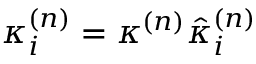<formula> <loc_0><loc_0><loc_500><loc_500>\kappa _ { i } ^ { ( n ) } = \kappa ^ { ( n ) } \hat { \kappa } _ { i } ^ { ( n ) }</formula> 